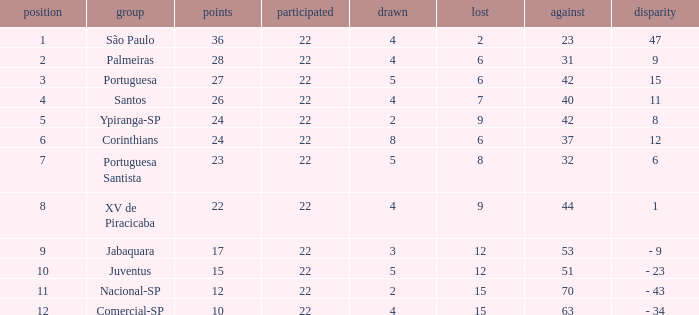Which Against has a Drawn smaller than 5, and a Lost smaller than 6, and a Points larger than 36? 0.0. 